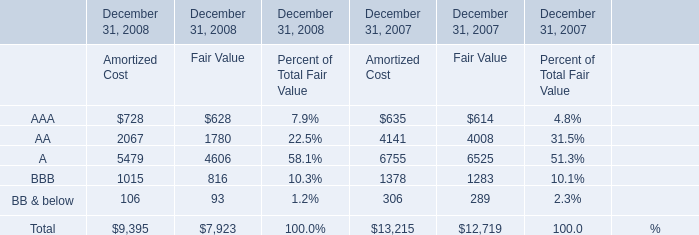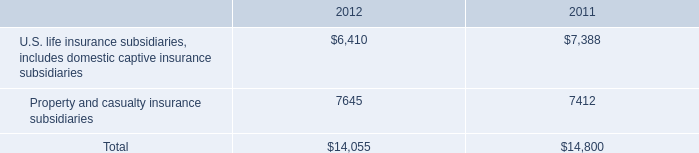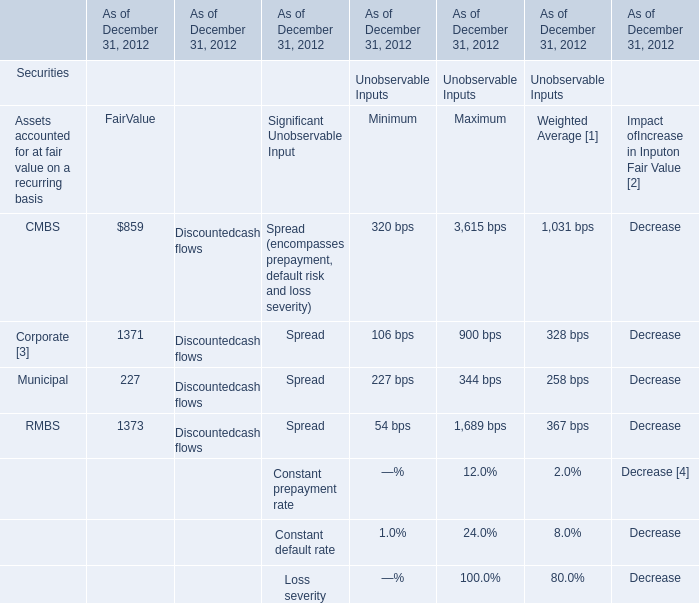what is the percentage change in statutory surplus from 2011 to 2012? 
Computations: ((14055 - 14800) / 14800)
Answer: -0.05034. 